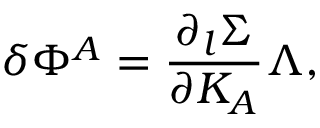Convert formula to latex. <formula><loc_0><loc_0><loc_500><loc_500>\delta \Phi ^ { A } = { \frac { \partial _ { l } \Sigma } { \partial K _ { A } } } \Lambda ,</formula> 